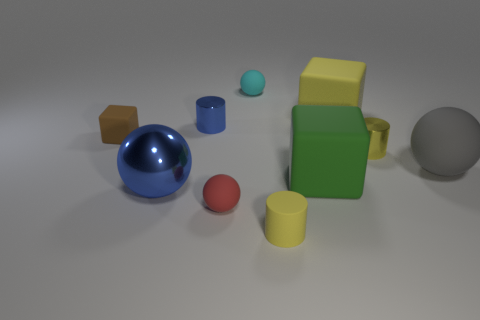What number of things are big green rubber things or yellow shiny blocks?
Your answer should be compact. 1. There is a matte ball that is right of the yellow cylinder behind the large sphere that is on the left side of the large gray rubber ball; what color is it?
Provide a short and direct response. Gray. Is there anything else of the same color as the matte cylinder?
Make the answer very short. Yes. Do the green rubber block and the yellow metallic cylinder have the same size?
Your answer should be compact. No. What number of objects are either tiny matte things that are right of the tiny blue metal thing or yellow cylinders that are behind the tiny red sphere?
Ensure brevity in your answer.  4. What is the large ball to the right of the yellow object in front of the big gray thing made of?
Make the answer very short. Rubber. How many other objects are the same material as the big blue thing?
Ensure brevity in your answer.  2. Is the shape of the brown object the same as the large green object?
Keep it short and to the point. Yes. There is a yellow object behind the brown rubber cube; what size is it?
Offer a very short reply. Large. Is the size of the green matte thing the same as the cylinder that is in front of the big blue thing?
Keep it short and to the point. No. 